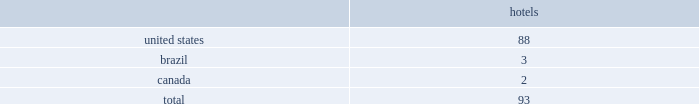Host hotels & resorts , inc. , host hotels & resorts , l.p. , and subsidiaries notes to consolidated financial statements 1 .
Summary of significant accounting policies description of business host hotels & resorts , inc .
Operates as a self-managed and self-administered real estate investment trust , or reit , with its operations conducted solely through host hotels & resorts , l.p .
Host hotels & resorts , l.p. , a delaware limited partnership , operates through an umbrella partnership structure , with host hotels & resorts , inc. , a maryland corporation , as its sole general partner .
In the notes to the consolidated financial statements , we use the terms 201cwe 201d or 201cour 201d to refer to host hotels & resorts , inc .
And host hotels & resorts , l.p .
Together , unless the context indicates otherwise .
We also use the term 201chost inc . 201d to refer specifically to host hotels & resorts , inc .
And the term 201chost l.p . 201d to refer specifically to host hotels & resorts , l.p .
In cases where it is important to distinguish between host inc .
And host l.p .
Host inc .
Holds approximately 99% ( 99 % ) of host l.p . 2019s partnership interests , or op units .
Consolidated portfolio as of december 31 , 2018 , the hotels in our consolidated portfolio are in the following countries: .
Basis of presentation and principles of consolidation the accompanying consolidated financial statements include the consolidated accounts of host inc. , host l.p .
And their subsidiaries and controlled affiliates , including joint ventures and partnerships .
We consolidate subsidiaries when we have the ability to control them .
For the majority of our hotel and real estate investments , we consider those control rights to be ( i ) approval or amendment of developments plans , ( ii ) financing decisions , ( iii ) approval or amendments of operating budgets , and ( iv ) investment strategy decisions .
We also evaluate our subsidiaries to determine if they are variable interest entities ( 201cvies 201d ) .
If a subsidiary is a vie , it is subject to the consolidation framework specifically for vies .
Typically , the entity that has the power to direct the activities that most significantly impact economic performance consolidates the vie .
We consider an entity to be a vie if equity investors own an interest therein that does not have the characteristics of a controlling financial interest or if such investors do not have sufficient equity at risk for the entity to finance its activities without additional subordinated financial support .
We review our subsidiaries and affiliates at least annually to determine if ( i ) they should be considered vies , and ( ii ) whether we should change our consolidation determination based on changes in the characteristics thereof .
Three partnerships are considered vie 2019s , as the general partner maintains control over the decisions that most significantly impact the partnerships .
The first vie is the operating partnership , host l.p. , which is consolidated by host inc. , of which host inc .
Is the general partner and holds 99% ( 99 % ) of the limited partner interests .
Host inc . 2019s sole significant asset is its investment in host l.p .
And substantially all of host inc . 2019s assets and liabilities represent assets and liabilities of host l.p .
All of host inc . 2019s debt is an obligation of host l.p .
And may be settled only with assets of host l.p .
The consolidated partnership that owns the houston airport marriott at george bush intercontinental , of which we are the general partner and hold 85% ( 85 % ) of the partnership interests , also is a vie .
The total assets of this vie at december 31 , 2018 are $ 48 million and consist primarily of cash and .
What percentage of hotel properties are in the united states? 
Computations: (88 / 93)
Answer: 0.94624. 